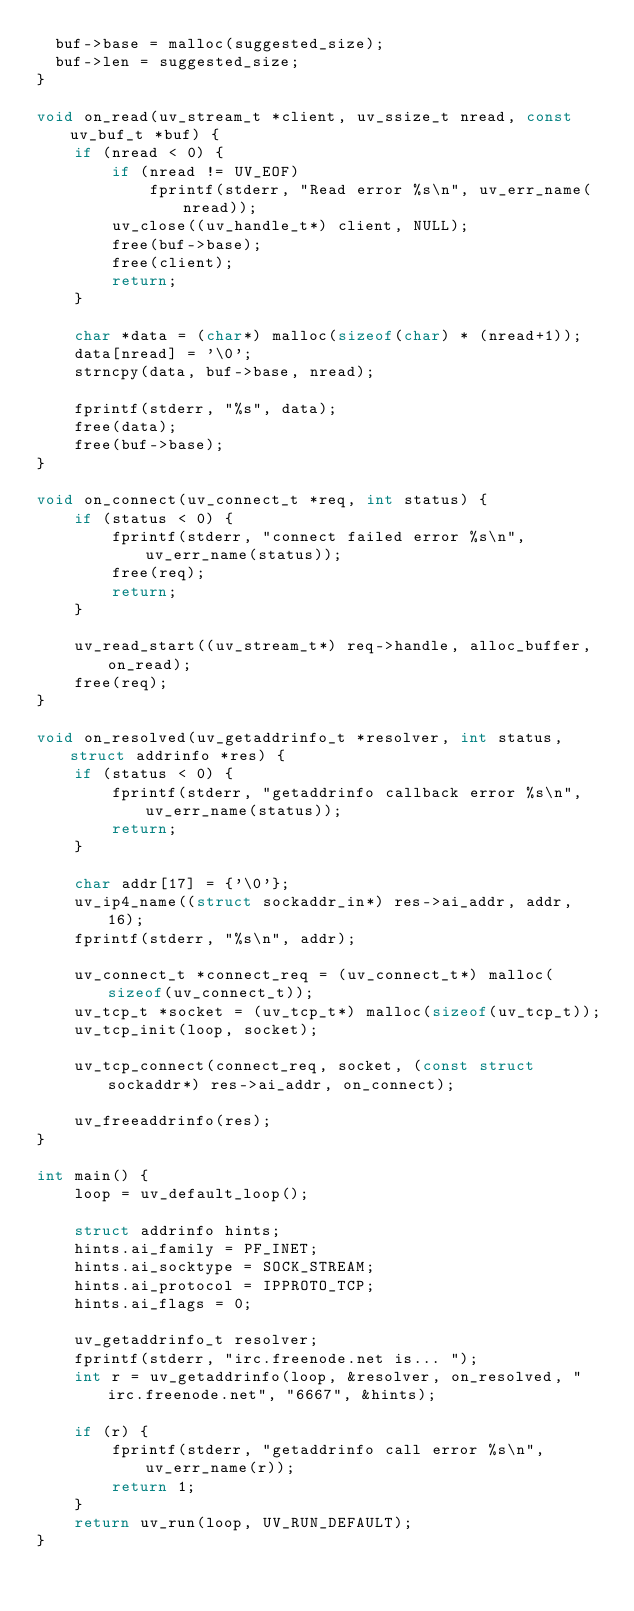Convert code to text. <code><loc_0><loc_0><loc_500><loc_500><_C_>  buf->base = malloc(suggested_size);
  buf->len = suggested_size;
}

void on_read(uv_stream_t *client, uv_ssize_t nread, const uv_buf_t *buf) {
    if (nread < 0) {
        if (nread != UV_EOF)
            fprintf(stderr, "Read error %s\n", uv_err_name(nread));
        uv_close((uv_handle_t*) client, NULL);
        free(buf->base);
        free(client);
        return;
    }

    char *data = (char*) malloc(sizeof(char) * (nread+1));
    data[nread] = '\0';
    strncpy(data, buf->base, nread);

    fprintf(stderr, "%s", data);
    free(data);
    free(buf->base);
}

void on_connect(uv_connect_t *req, int status) {
    if (status < 0) {
        fprintf(stderr, "connect failed error %s\n", uv_err_name(status));
        free(req);
        return;
    }

    uv_read_start((uv_stream_t*) req->handle, alloc_buffer, on_read);
    free(req);
}

void on_resolved(uv_getaddrinfo_t *resolver, int status, struct addrinfo *res) {
    if (status < 0) {
        fprintf(stderr, "getaddrinfo callback error %s\n", uv_err_name(status));
        return;
    }

    char addr[17] = {'\0'};
    uv_ip4_name((struct sockaddr_in*) res->ai_addr, addr, 16);
    fprintf(stderr, "%s\n", addr);

    uv_connect_t *connect_req = (uv_connect_t*) malloc(sizeof(uv_connect_t));
    uv_tcp_t *socket = (uv_tcp_t*) malloc(sizeof(uv_tcp_t));
    uv_tcp_init(loop, socket);

    uv_tcp_connect(connect_req, socket, (const struct sockaddr*) res->ai_addr, on_connect);

    uv_freeaddrinfo(res);
}

int main() {
    loop = uv_default_loop();

    struct addrinfo hints;
    hints.ai_family = PF_INET;
    hints.ai_socktype = SOCK_STREAM;
    hints.ai_protocol = IPPROTO_TCP;
    hints.ai_flags = 0;

    uv_getaddrinfo_t resolver;
    fprintf(stderr, "irc.freenode.net is... ");
    int r = uv_getaddrinfo(loop, &resolver, on_resolved, "irc.freenode.net", "6667", &hints);

    if (r) {
        fprintf(stderr, "getaddrinfo call error %s\n", uv_err_name(r));
        return 1;
    }
    return uv_run(loop, UV_RUN_DEFAULT);
}
</code> 